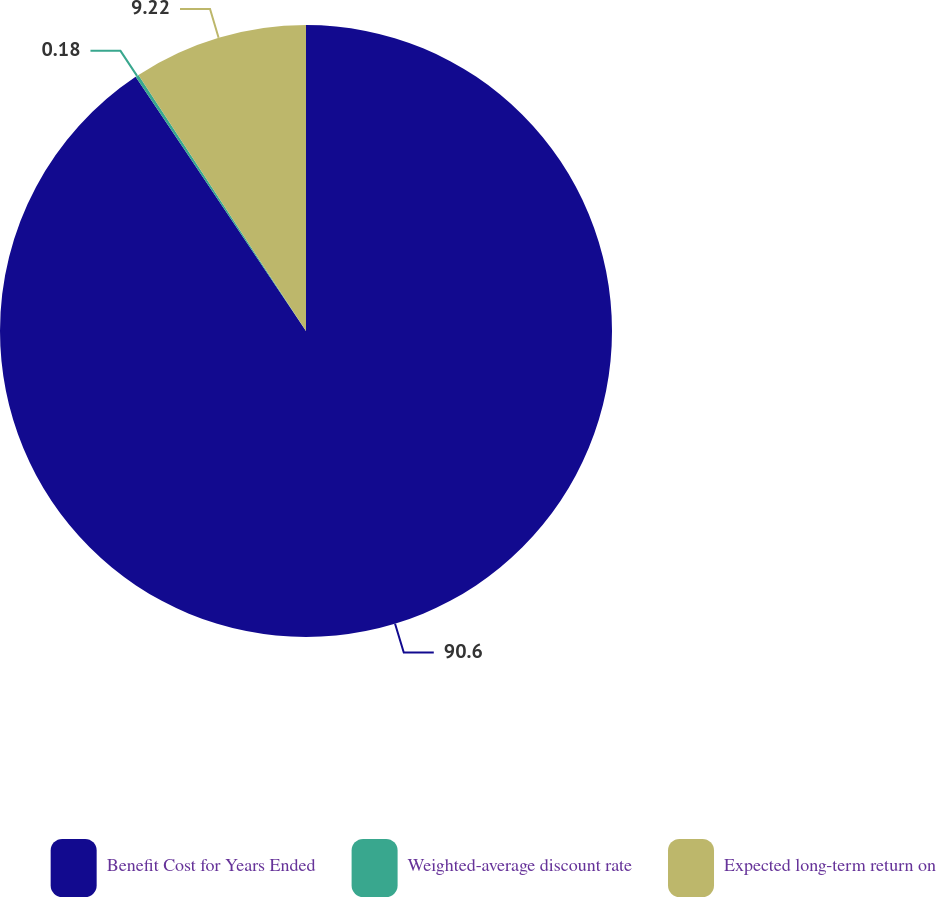Convert chart. <chart><loc_0><loc_0><loc_500><loc_500><pie_chart><fcel>Benefit Cost for Years Ended<fcel>Weighted-average discount rate<fcel>Expected long-term return on<nl><fcel>90.6%<fcel>0.18%<fcel>9.22%<nl></chart> 